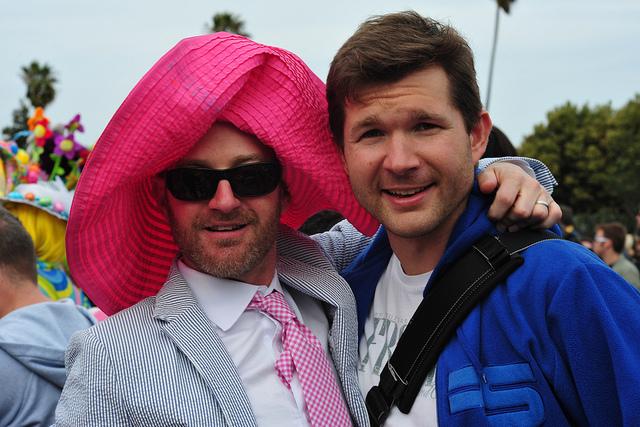Which man appears to have shaved more recently?
Write a very short answer. Man on right. Is the man wearing a pink tie?
Concise answer only. Yes. What color is the hat the man is wearing?
Concise answer only. Pink. 